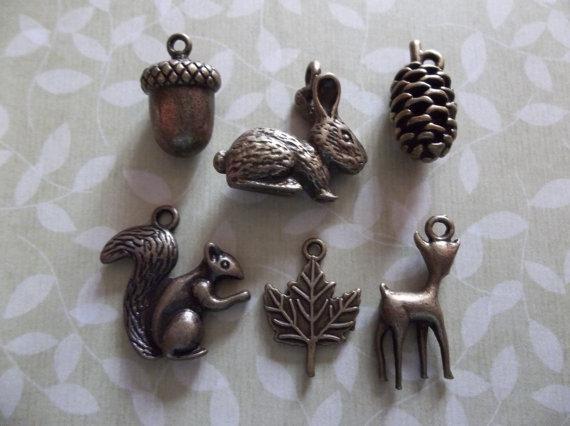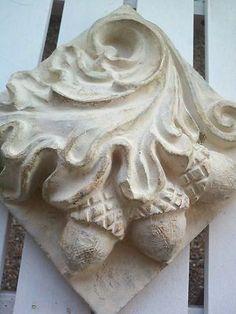The first image is the image on the left, the second image is the image on the right. Evaluate the accuracy of this statement regarding the images: "An image includes charms shaped like a rabbit, an acorn and a pinecone, displayed on a surface decorated with a foliage pattern.". Is it true? Answer yes or no. Yes. The first image is the image on the left, the second image is the image on the right. Assess this claim about the two images: "At least one object is made of wood.". Correct or not? Answer yes or no. No. 